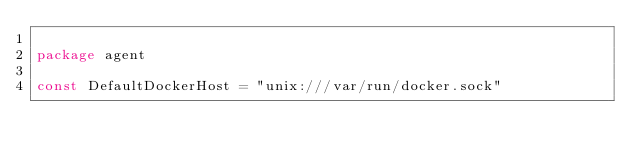Convert code to text. <code><loc_0><loc_0><loc_500><loc_500><_Go_>
package agent

const DefaultDockerHost = "unix:///var/run/docker.sock"
</code> 